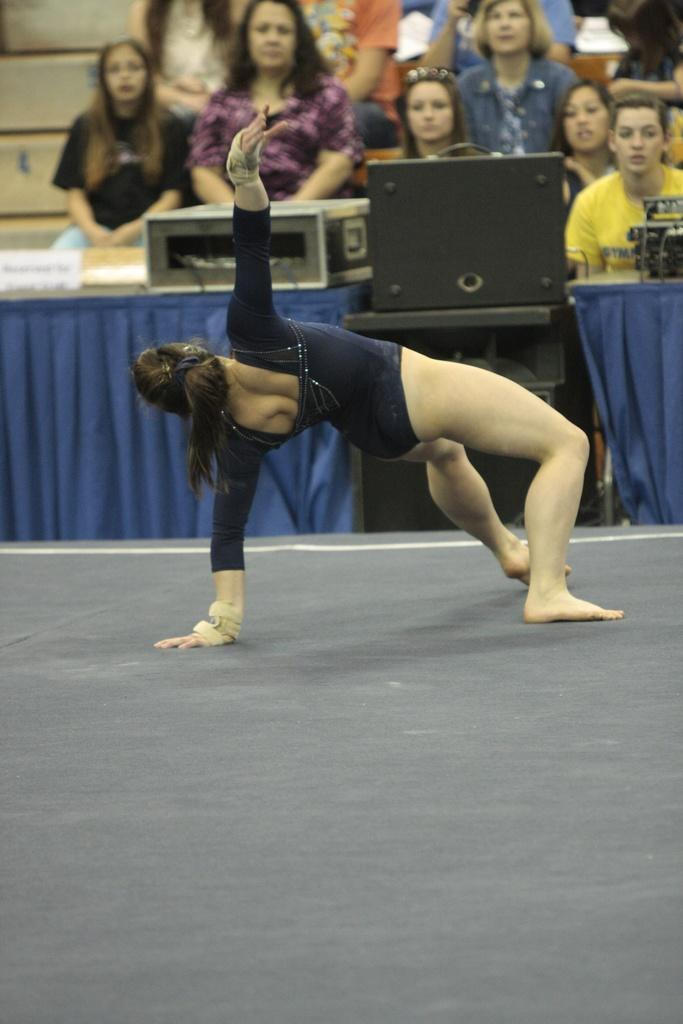What activity is the person in the image performing? The person in the image is doing gymnastics. What can be seen in the background of the image? There are speakers, objects on a table, and a group of people sitting in the background of the image. What type of chicken is being used to cause a commotion in the image? There is no chicken present in the image, and therefore no commotion caused by a chicken can be observed. 